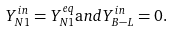<formula> <loc_0><loc_0><loc_500><loc_500>Y ^ { i n } _ { N 1 } = Y ^ { e q } _ { N 1 } { \mathrm a n d } Y ^ { i n } _ { B - L } = 0 .</formula> 